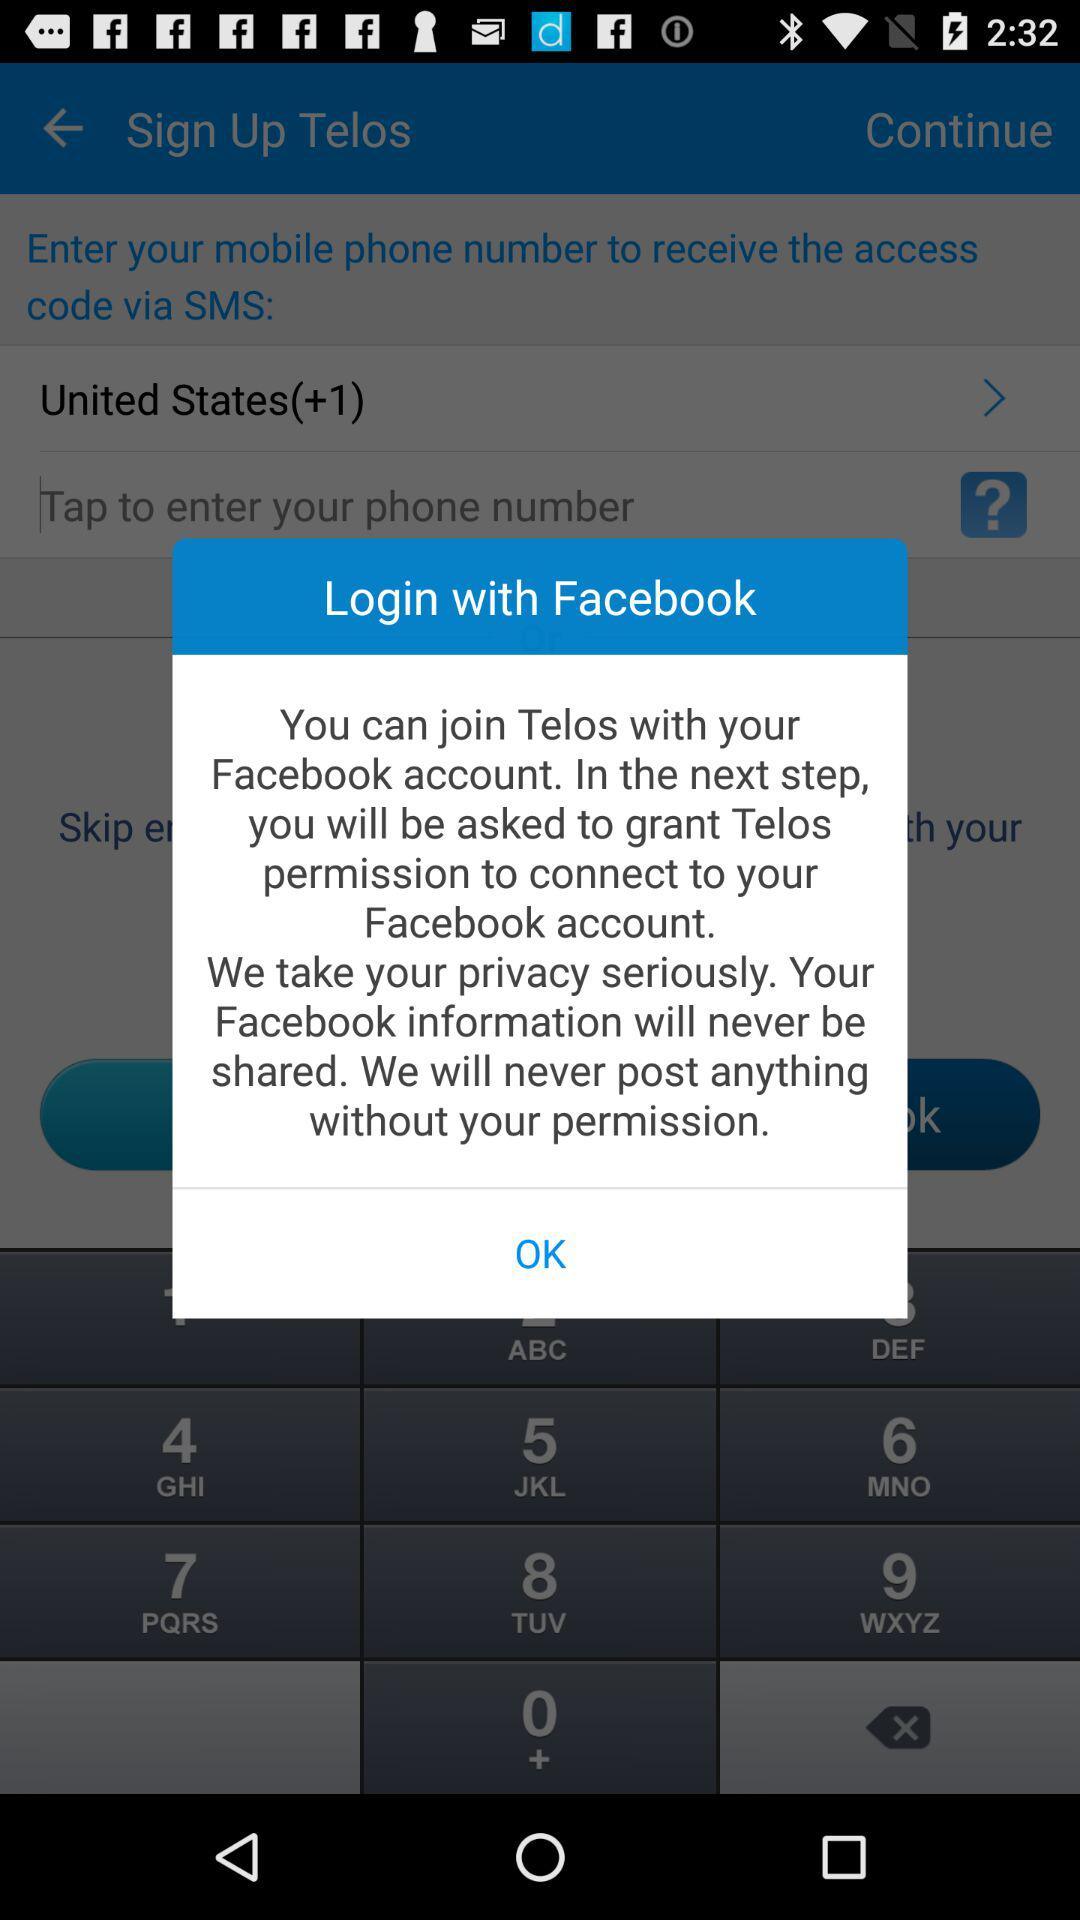By what account can logging in be done? Logging in can be done with the "Facebook" account. 